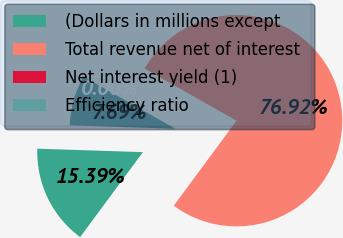<chart> <loc_0><loc_0><loc_500><loc_500><pie_chart><fcel>(Dollars in millions except<fcel>Total revenue net of interest<fcel>Net interest yield (1)<fcel>Efficiency ratio<nl><fcel>15.39%<fcel>76.92%<fcel>0.0%<fcel>7.69%<nl></chart> 